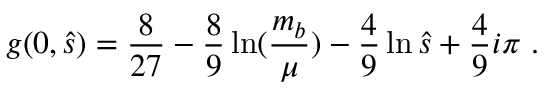Convert formula to latex. <formula><loc_0><loc_0><loc_500><loc_500>g ( 0 , \hat { s } ) = \frac { 8 } { 2 7 } - \frac { 8 } { 9 } \ln ( \frac { m _ { b } } { \mu } ) - \frac { 4 } { 9 } \ln \hat { s } + \frac { 4 } { 9 } i \pi .</formula> 